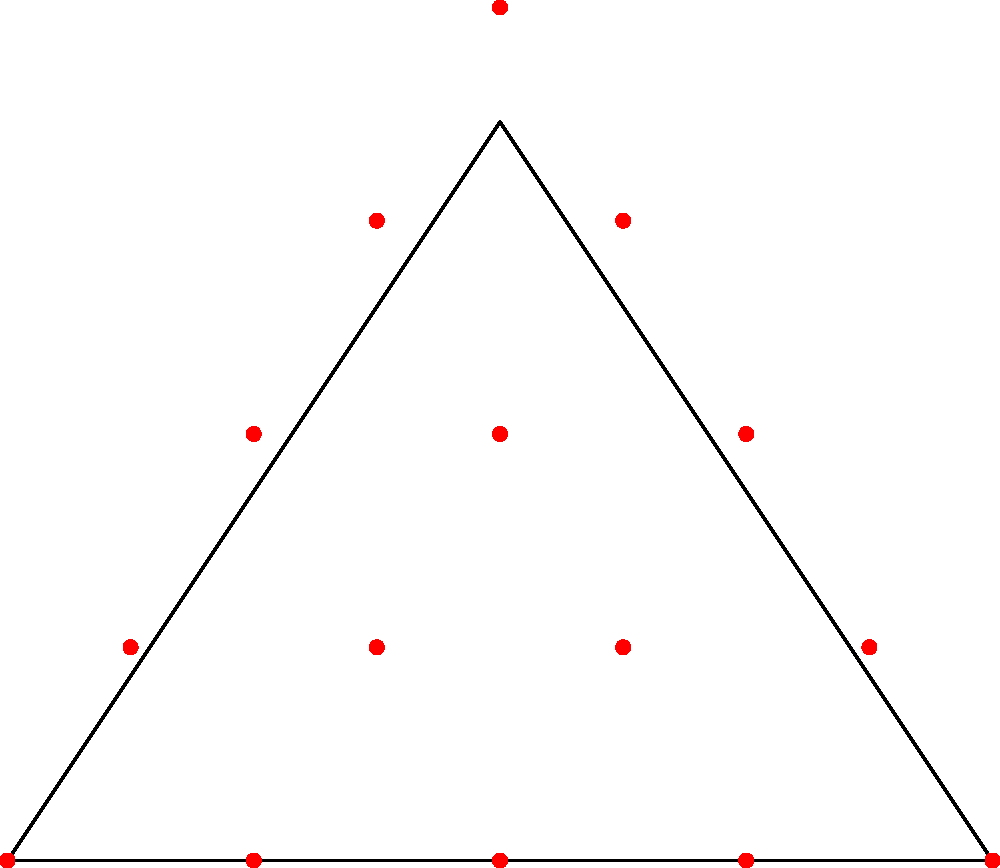After the flood, you decide to replant your triangular field using an efficient hexagonal pattern. If the field is an equilateral triangle with side length 4 units, how many plants can be placed in the field if the centers of adjacent plants are 1 unit apart? To solve this problem, we'll follow these steps:

1) First, we need to understand that the hexagonal pattern forms equilateral triangles between adjacent plants.

2) The plants are placed at the vertices of these smaller equilateral triangles, with centers 1 unit apart.

3) We can overlay this pattern onto our larger equilateral triangle field.

4) To count the plants, we can count row by row:
   - The bottom row will have 5 plants (4 intervals of 1 unit)
   - The next row up will have 4 plants
   - Then 3, 2, and finally 1 plant at the top

5) To calculate the total:
   $$5 + 4 + 3 + 2 + 1 = 15$$

6) This sum follows the pattern of triangular numbers, which can be calculated using the formula:
   $$\frac{n(n+1)}{2}$$
   where $n$ is the number of rows (in this case, 5).

7) We can verify: $$\frac{5(5+1)}{2} = \frac{5(6)}{2} = \frac{30}{2} = 15$$

Therefore, 15 plants can be efficiently placed in the triangular field using this hexagonal pattern.
Answer: 15 plants 